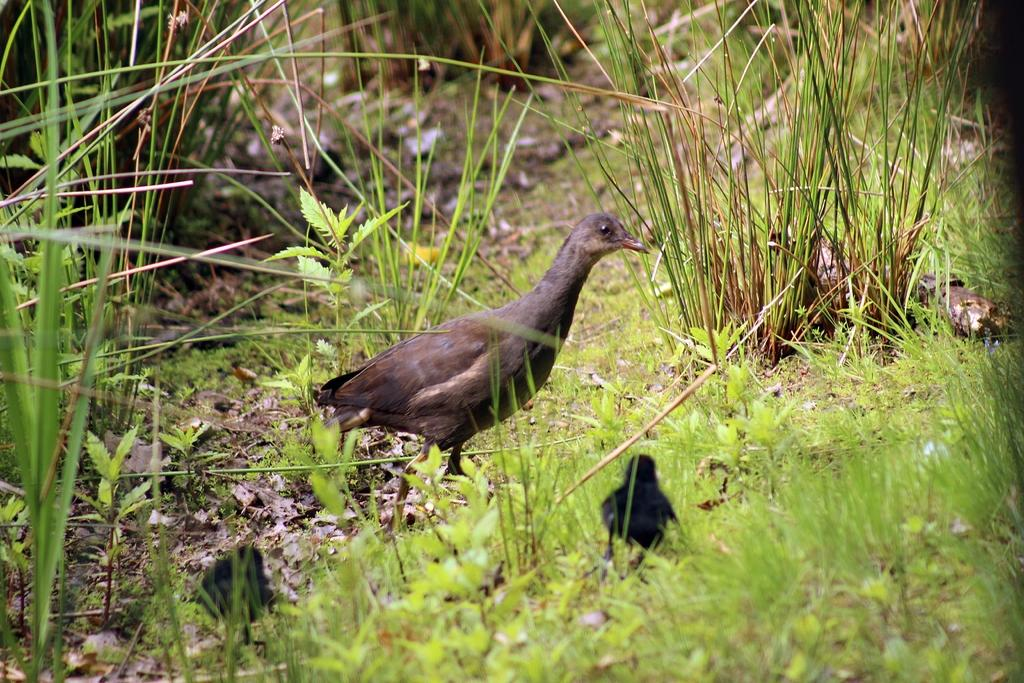What type of animals can be seen on the land in the image? There are birds on the land in the image. What can be seen growing in the image? There are plants visible in the image. What type of vegetation is present in the image? There is grass visible in the image. What colors are the birds in the image? The birds are in brown and black colors. Can you tell me how many eyes the birds have in the image? The image does not show the eyes of the birds, so it is not possible to determine how many eyes they have. 